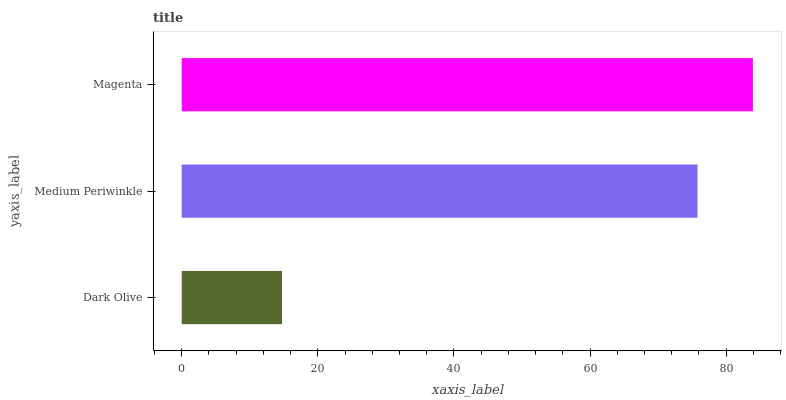Is Dark Olive the minimum?
Answer yes or no. Yes. Is Magenta the maximum?
Answer yes or no. Yes. Is Medium Periwinkle the minimum?
Answer yes or no. No. Is Medium Periwinkle the maximum?
Answer yes or no. No. Is Medium Periwinkle greater than Dark Olive?
Answer yes or no. Yes. Is Dark Olive less than Medium Periwinkle?
Answer yes or no. Yes. Is Dark Olive greater than Medium Periwinkle?
Answer yes or no. No. Is Medium Periwinkle less than Dark Olive?
Answer yes or no. No. Is Medium Periwinkle the high median?
Answer yes or no. Yes. Is Medium Periwinkle the low median?
Answer yes or no. Yes. Is Magenta the high median?
Answer yes or no. No. Is Dark Olive the low median?
Answer yes or no. No. 